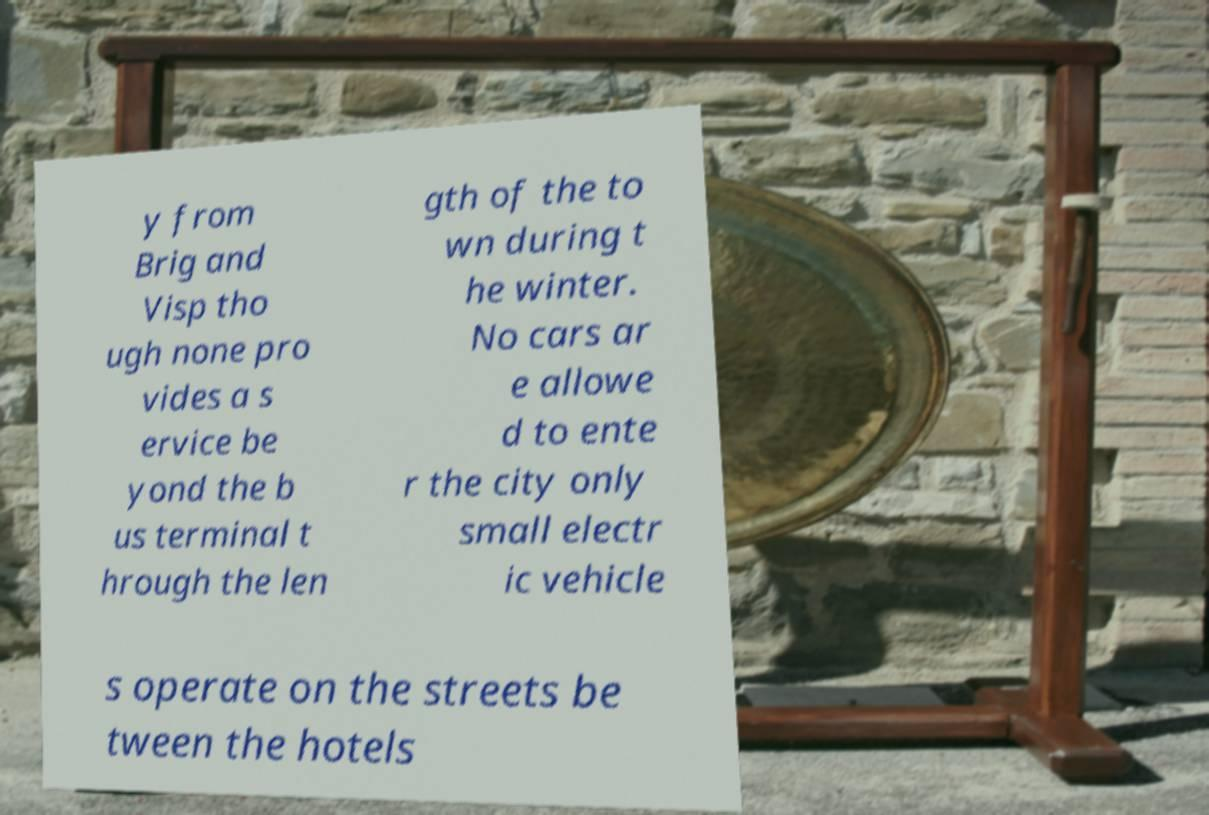Could you extract and type out the text from this image? y from Brig and Visp tho ugh none pro vides a s ervice be yond the b us terminal t hrough the len gth of the to wn during t he winter. No cars ar e allowe d to ente r the city only small electr ic vehicle s operate on the streets be tween the hotels 